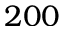Convert formula to latex. <formula><loc_0><loc_0><loc_500><loc_500>2 0 0</formula> 